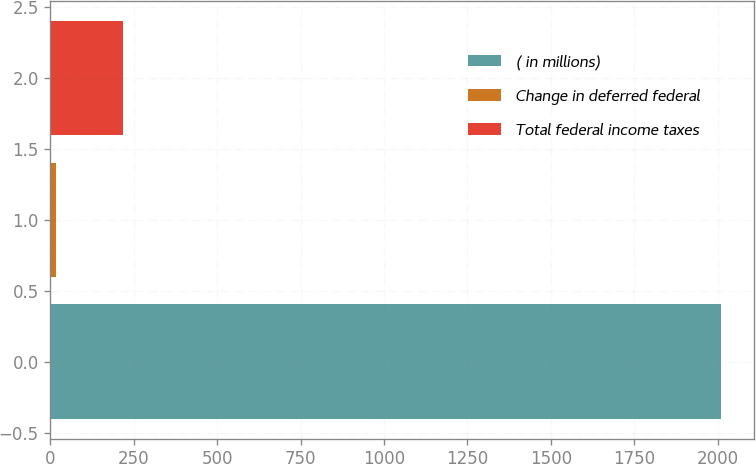Convert chart to OTSL. <chart><loc_0><loc_0><loc_500><loc_500><bar_chart><fcel>( in millions)<fcel>Change in deferred federal<fcel>Total federal income taxes<nl><fcel>2010<fcel>18<fcel>217.2<nl></chart> 